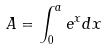Convert formula to latex. <formula><loc_0><loc_0><loc_500><loc_500>A = \int _ { 0 } ^ { a } e ^ { x } d x</formula> 